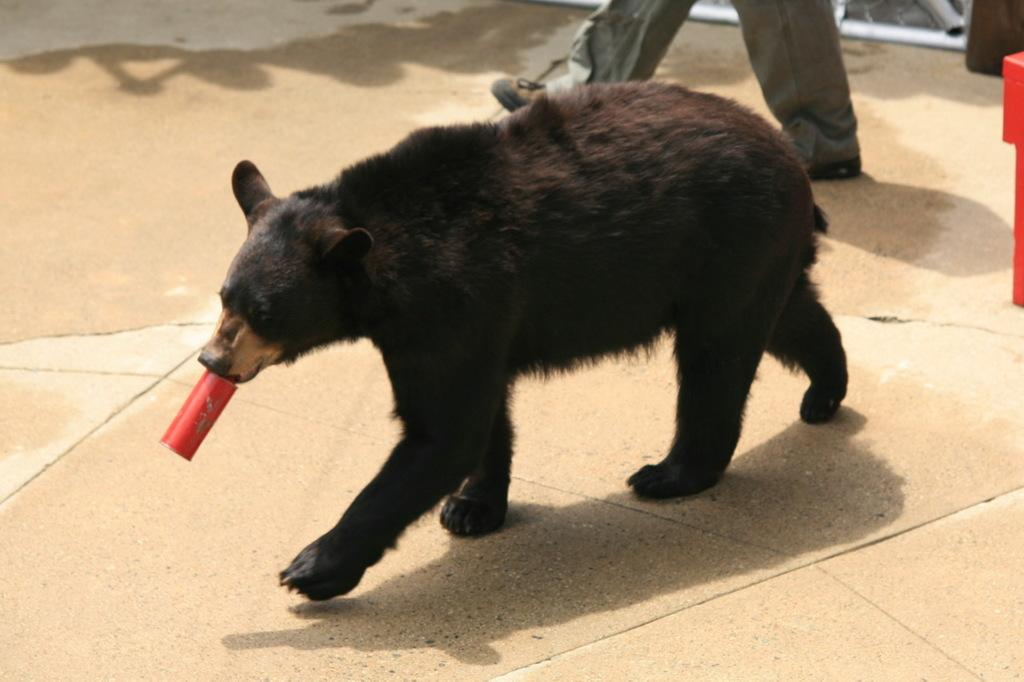What animal is present in the image? There is a bear in the image. What is the bear holding in its hand? The bear is holding a tin. What surface is the bear walking on? The bear is walking on a pavement. Can you describe the background of the image? There is a man in the background of the image. What type of letter is the bear writing to the man in the background? There is no indication in the image that the bear is writing a letter or interacting with the man in the background. 